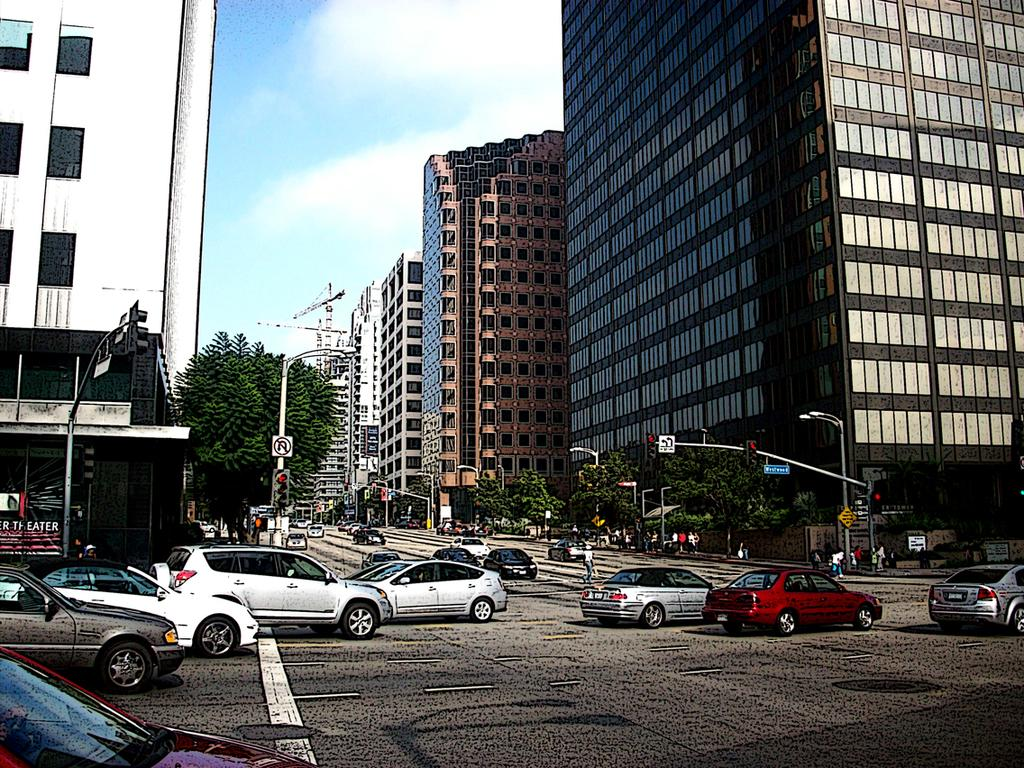What type of structures can be seen in the image? There are buildings in the image. What other natural elements are present in the image? There are trees in the image. What man-made objects can be seen in the image? There are poles and boards visible in the image. What mode of transportation can be seen on the road at the bottom of the image? There are cars on the road at the bottom of the image. Are there any living beings visible in the image? Yes, there are people visible in the image. What is visible in the background of the image? The sky is visible in the background of the image. What company is responsible for the twist in the road in the image? There is no twist in the road in the image, and therefore no company is associated with it. What do people believe about the trees in the image? The image does not provide any information about people's beliefs regarding the trees, so it cannot be determined from the image. 